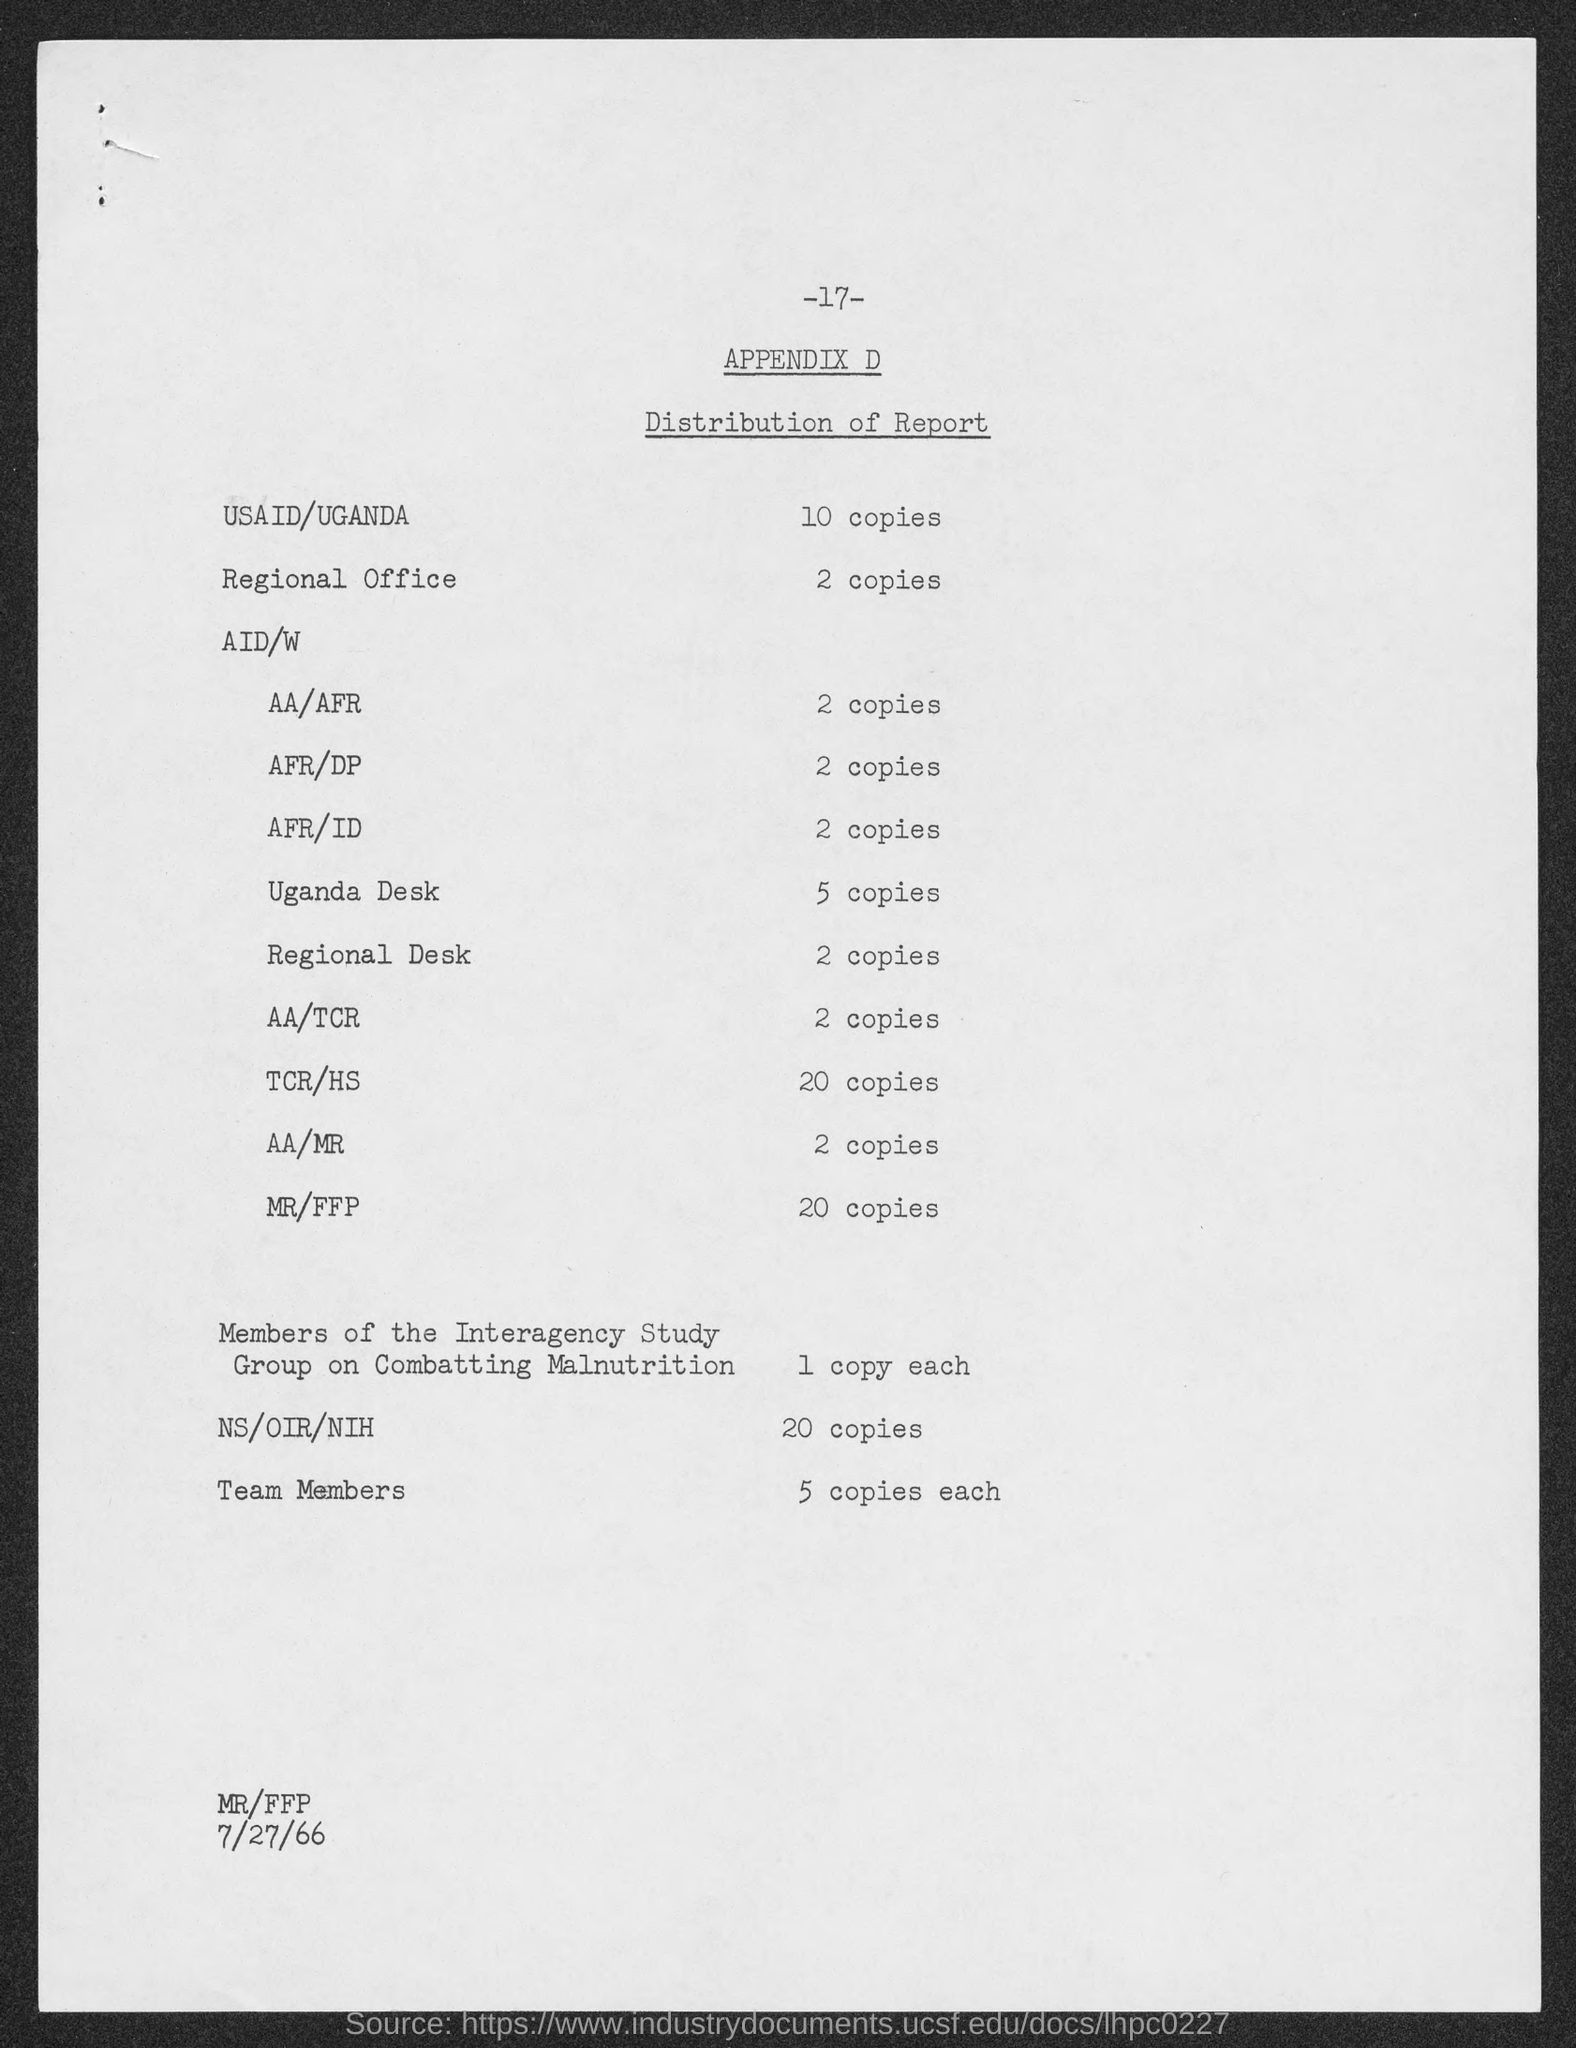What is the page no mentioned in this document?
Provide a succinct answer. 17. How many copies of the report are distributed in the regional office?
Keep it short and to the point. 2. What is the no of copies distributed in Uganda Desk?
Ensure brevity in your answer.  5 copies. What is the no of copies distributed in NS/OIR/NIH?
Your answer should be compact. 20. How many copies of the report are distributed in USAID/UGANDA?
Give a very brief answer. 10. What is the date mentioned in this document?
Ensure brevity in your answer.  7/27/66. What is the no of copies distributed in the regional desk?
Provide a short and direct response. 2. How many copies of the report are distributed in MR/ FFP?
Make the answer very short. 20 copies. 